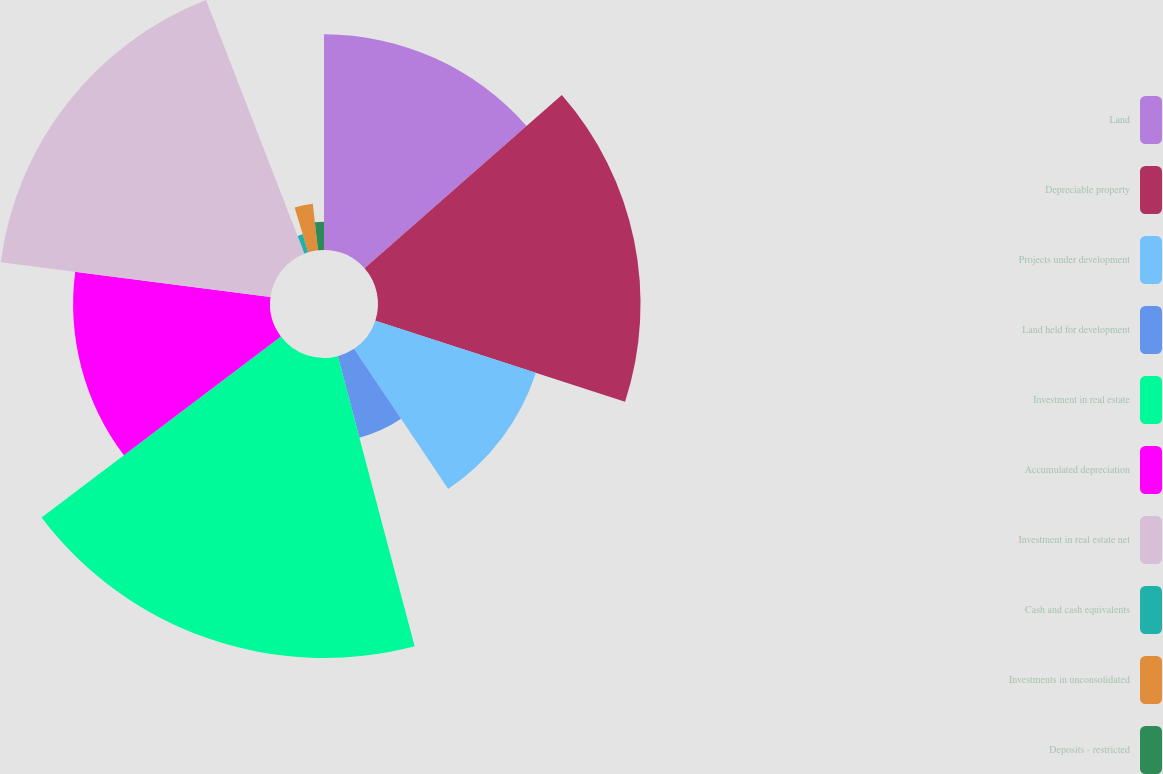Convert chart. <chart><loc_0><loc_0><loc_500><loc_500><pie_chart><fcel>Land<fcel>Depreciable property<fcel>Projects under development<fcel>Land held for development<fcel>Investment in real estate<fcel>Accumulated depreciation<fcel>Investment in real estate net<fcel>Cash and cash equivalents<fcel>Investments in unconsolidated<fcel>Deposits - restricted<nl><fcel>13.53%<fcel>16.47%<fcel>10.59%<fcel>5.29%<fcel>18.82%<fcel>12.35%<fcel>17.06%<fcel>1.18%<fcel>2.94%<fcel>1.77%<nl></chart> 